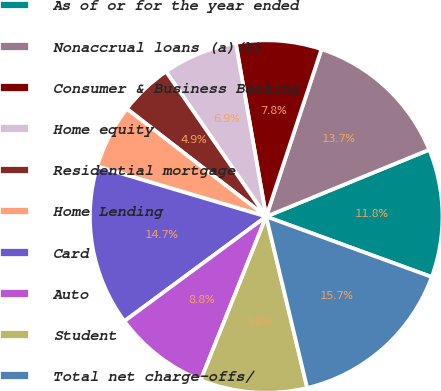<chart> <loc_0><loc_0><loc_500><loc_500><pie_chart><fcel>As of or for the year ended<fcel>Nonaccrual loans (a)(b)<fcel>Consumer & Business Banking<fcel>Home equity<fcel>Residential mortgage<fcel>Home Lending<fcel>Card<fcel>Auto<fcel>Student<fcel>Total net charge-offs/<nl><fcel>11.76%<fcel>13.73%<fcel>7.84%<fcel>6.86%<fcel>4.9%<fcel>5.88%<fcel>14.71%<fcel>8.82%<fcel>9.8%<fcel>15.69%<nl></chart> 